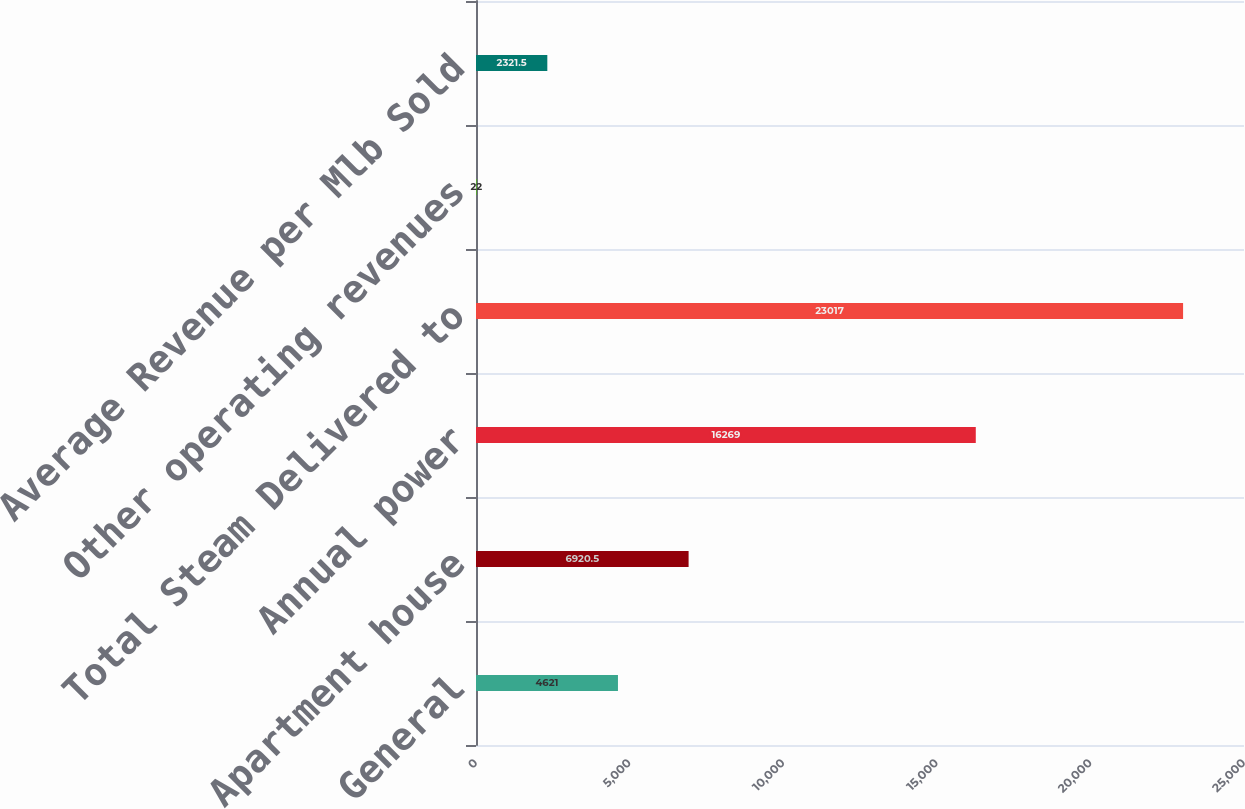<chart> <loc_0><loc_0><loc_500><loc_500><bar_chart><fcel>General<fcel>Apartment house<fcel>Annual power<fcel>Total Steam Delivered to<fcel>Other operating revenues<fcel>Average Revenue per Mlb Sold<nl><fcel>4621<fcel>6920.5<fcel>16269<fcel>23017<fcel>22<fcel>2321.5<nl></chart> 